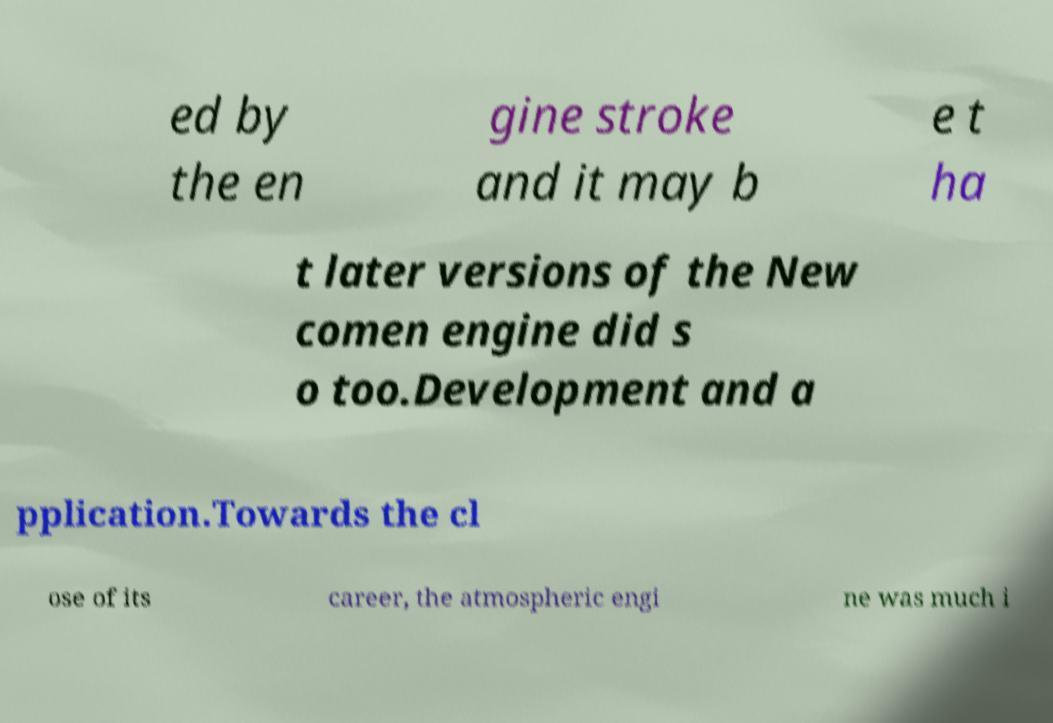Can you accurately transcribe the text from the provided image for me? ed by the en gine stroke and it may b e t ha t later versions of the New comen engine did s o too.Development and a pplication.Towards the cl ose of its career, the atmospheric engi ne was much i 